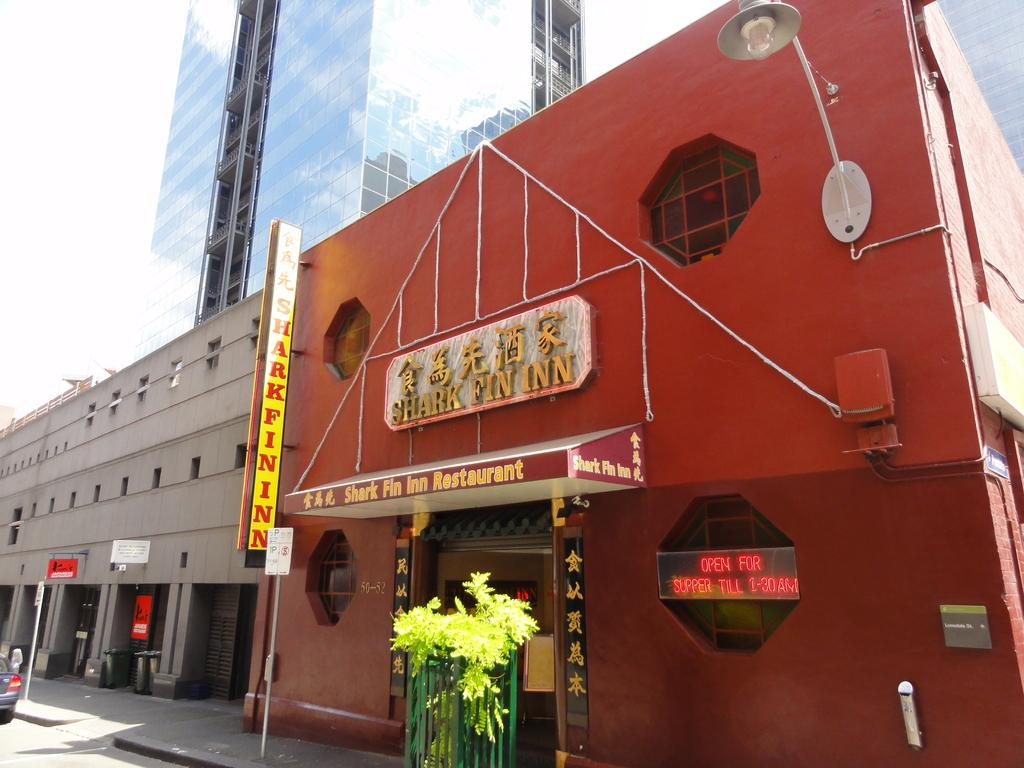What type of structures are visible in the image? There are buildings in the image. What can be seen on the road in the image? There is a car parked on the road in the image. What is the condition of the sky in the image? The sky is clear in the image. What type of produce is hanging from the buildings in the image? There is no produce visible in the image; only buildings, a car, and the sky are present. Can you hear a bell ringing in the image? There is no auditory information provided in the image, so it is impossible to determine if a bell is ringing. 